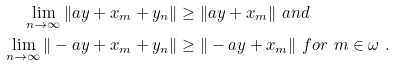Convert formula to latex. <formula><loc_0><loc_0><loc_500><loc_500>\lim _ { n \to \infty } \| a y + x _ { m } + y _ { n } \| & \geq \| a y + x _ { m } \| \ a n d \\ \lim _ { n \to \infty } \| - a y + x _ { m } + y _ { n } \| & \geq \| - a y + x _ { m } \| \ f o r \ m \in \omega \ .</formula> 